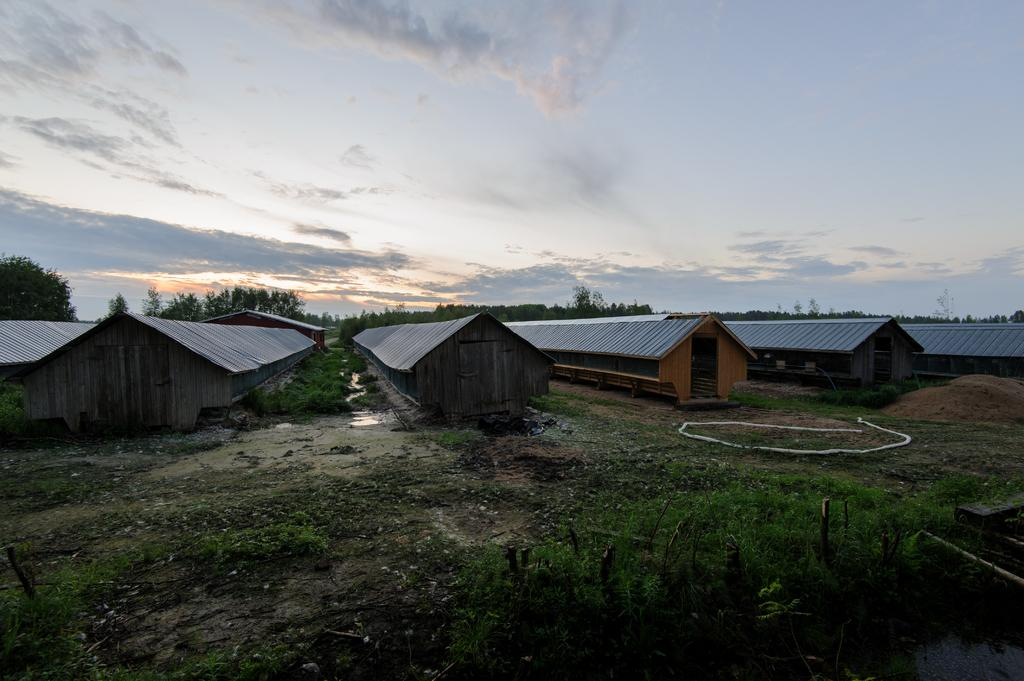What type of structures can be seen on the grassland in the image? There are godowns on the grassland in the image. What can be seen in the background of the image? There are trees in the background of the image. What is visible in the sky in the image? The sky is visible in the image, and clouds are present. What type of feeling does the snake in the image have? There is no snake present in the image, so it is not possible to determine the feeling of a snake. 